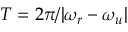Convert formula to latex. <formula><loc_0><loc_0><loc_500><loc_500>T = 2 \pi / | \omega _ { r } - \omega _ { u } |</formula> 